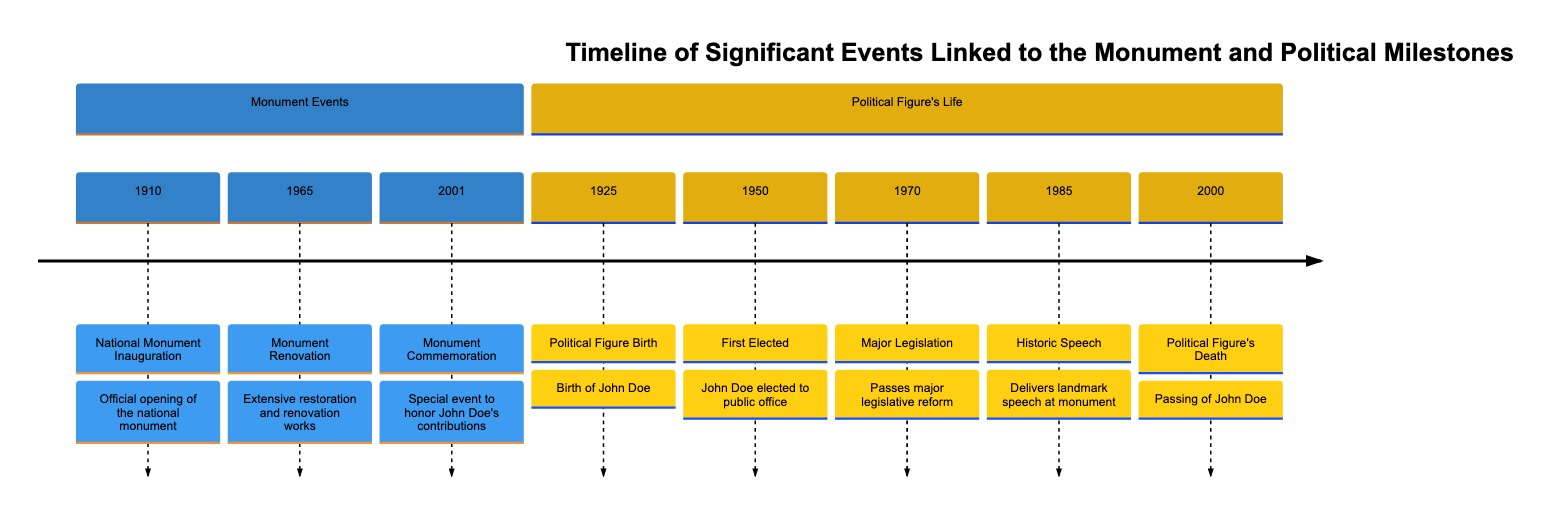What year was the national monument inaugurated? The diagram lists "National Monument Inauguration" under the section "Monument Events" with the corresponding year of 1910.
Answer: 1910 What significant event occurred in 1965? The timeline shows "Monument Renovation" as the event that took place in 1965 under the "Monument Events" section.
Answer: Monument Renovation How many major political milestones are listed? The section "Political Figure's Life" contains five distinct events which are counted to determine the total.
Answer: 5 What landmark speech was delivered in 1985? Looking at the "Political Figure's Life" section, it specifies "Historic Speech" as the event for the year 1985.
Answer: Historic Speech What event commemorated John Doe's contributions? The diagram states that in 2001, there was a "Monument Commemoration" event specifically honoring John Doe.
Answer: Monument Commemoration What year did John Doe first get elected to public office? According to the timeline, the event of John Doe being "First Elected" is marked in 1950 under the relevant section.
Answer: 1950 Which event marks the political figure's death? The event titled "Political Figure's Death" under the "Political Figure's Life" section indicates the year 2000.
Answer: Political Figure's Death Which significant event took place right before the monument's commemoration? The timeline shows "Monument Commemoration" happening in 2001, following "Monument Renovation" from 1965. The events are sequential.
Answer: Monument Renovation What major legislative reform did John Doe pass? The diagram lists "Major Legislation" as the event for 1970, indicating a major reform associated with John Doe's political career.
Answer: Major Legislation What major event happened in the same decade as the national monument's inauguration? The timeline shows that John Doe was born in 1925, which is in the decade preceding the inauguration of the national monument in 1910.
Answer: Political Figure Birth 